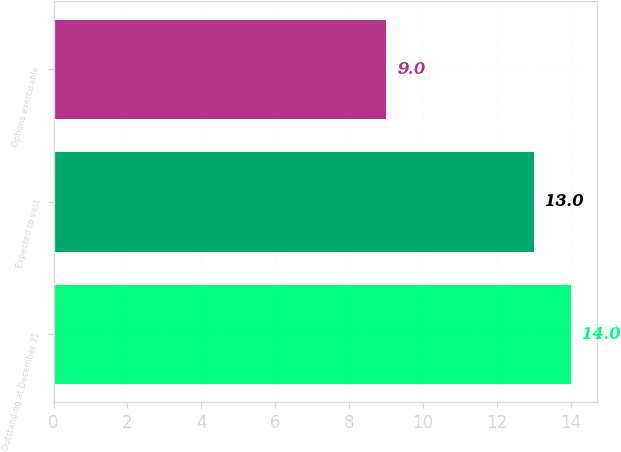Convert chart. <chart><loc_0><loc_0><loc_500><loc_500><bar_chart><fcel>Outstanding at December 31<fcel>Expected to vest<fcel>Options exercisable<nl><fcel>14<fcel>13<fcel>9<nl></chart> 